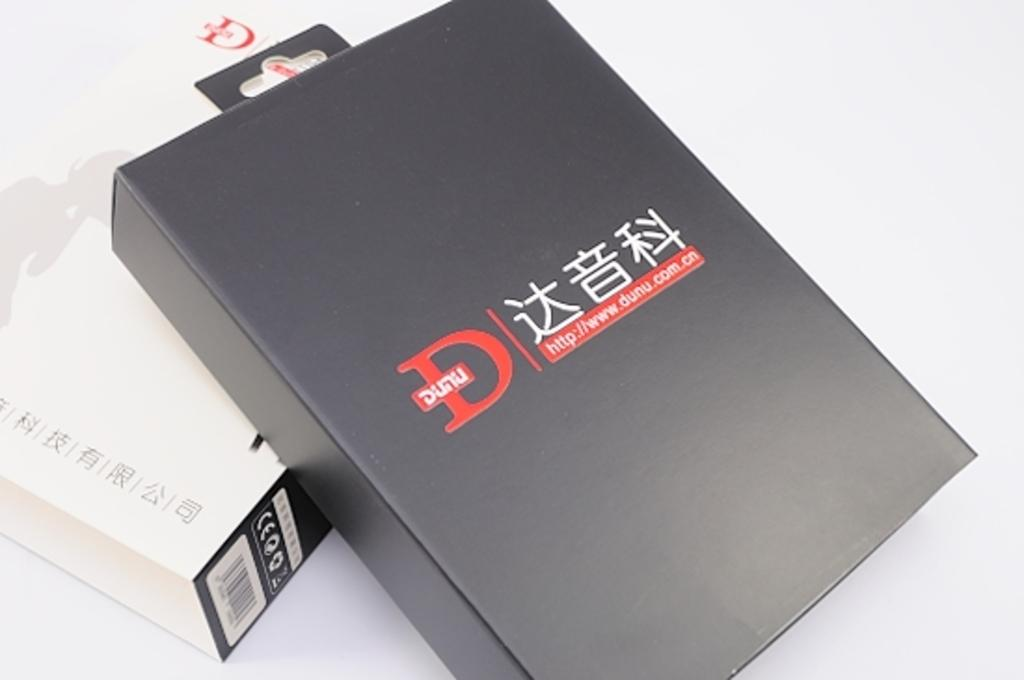Provide a one-sentence caption for the provided image. A black box with a hanging tag and a dunu.com website on it. 